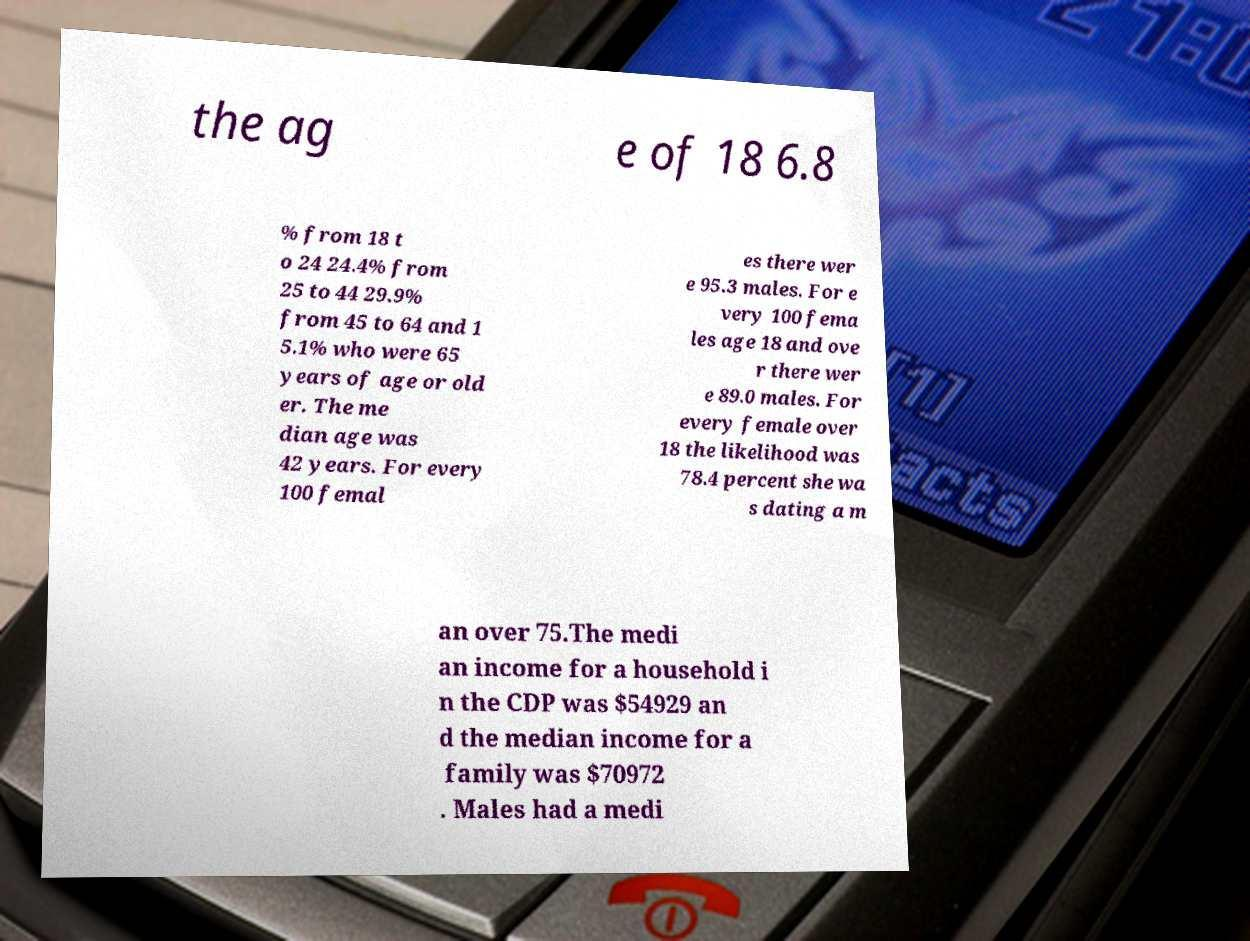I need the written content from this picture converted into text. Can you do that? the ag e of 18 6.8 % from 18 t o 24 24.4% from 25 to 44 29.9% from 45 to 64 and 1 5.1% who were 65 years of age or old er. The me dian age was 42 years. For every 100 femal es there wer e 95.3 males. For e very 100 fema les age 18 and ove r there wer e 89.0 males. For every female over 18 the likelihood was 78.4 percent she wa s dating a m an over 75.The medi an income for a household i n the CDP was $54929 an d the median income for a family was $70972 . Males had a medi 